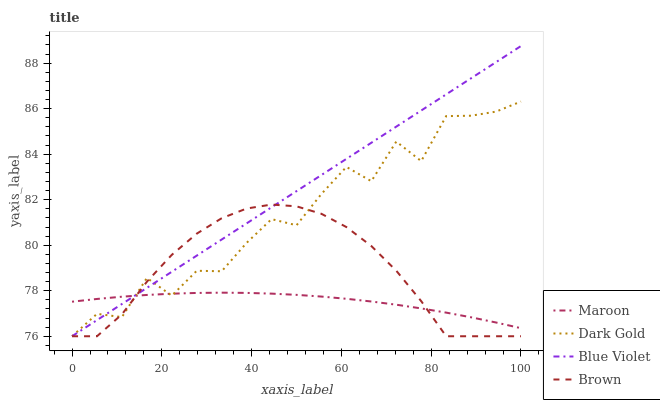Does Maroon have the minimum area under the curve?
Answer yes or no. Yes. Does Blue Violet have the minimum area under the curve?
Answer yes or no. No. Does Maroon have the maximum area under the curve?
Answer yes or no. No. Is Blue Violet the smoothest?
Answer yes or no. Yes. Is Dark Gold the roughest?
Answer yes or no. Yes. Is Maroon the smoothest?
Answer yes or no. No. Is Maroon the roughest?
Answer yes or no. No. Does Maroon have the lowest value?
Answer yes or no. No. Does Maroon have the highest value?
Answer yes or no. No. 